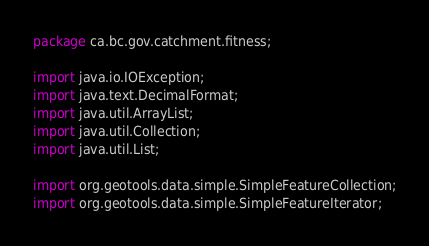<code> <loc_0><loc_0><loc_500><loc_500><_Java_>package ca.bc.gov.catchment.fitness;

import java.io.IOException;
import java.text.DecimalFormat;
import java.util.ArrayList;
import java.util.Collection;
import java.util.List;

import org.geotools.data.simple.SimpleFeatureCollection;
import org.geotools.data.simple.SimpleFeatureIterator;</code> 